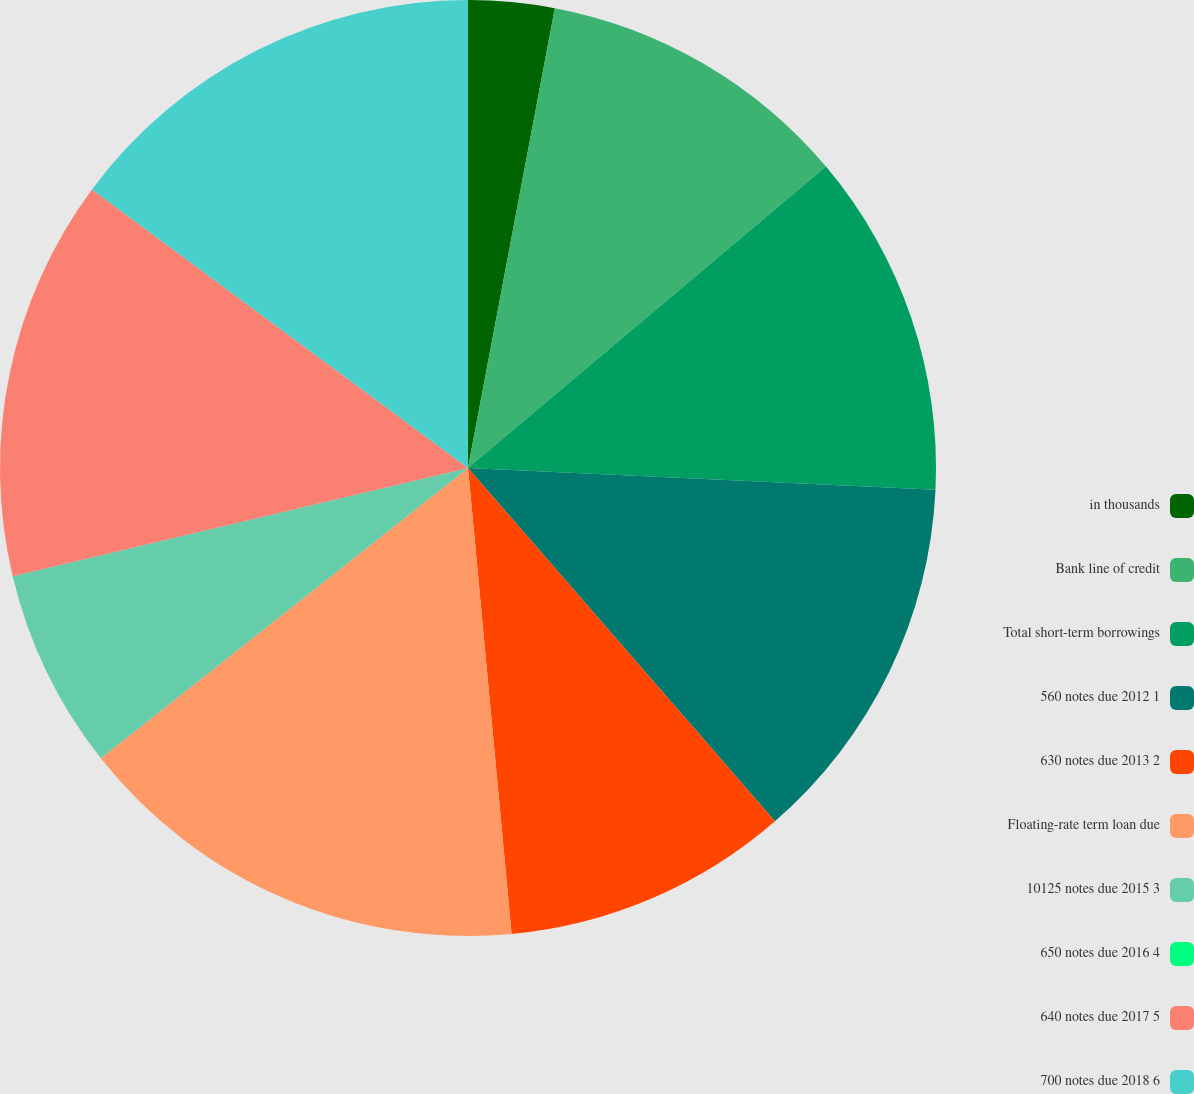<chart> <loc_0><loc_0><loc_500><loc_500><pie_chart><fcel>in thousands<fcel>Bank line of credit<fcel>Total short-term borrowings<fcel>560 notes due 2012 1<fcel>630 notes due 2013 2<fcel>Floating-rate term loan due<fcel>10125 notes due 2015 3<fcel>650 notes due 2016 4<fcel>640 notes due 2017 5<fcel>700 notes due 2018 6<nl><fcel>2.97%<fcel>10.89%<fcel>11.88%<fcel>12.87%<fcel>9.9%<fcel>15.84%<fcel>6.93%<fcel>0.0%<fcel>13.86%<fcel>14.85%<nl></chart> 